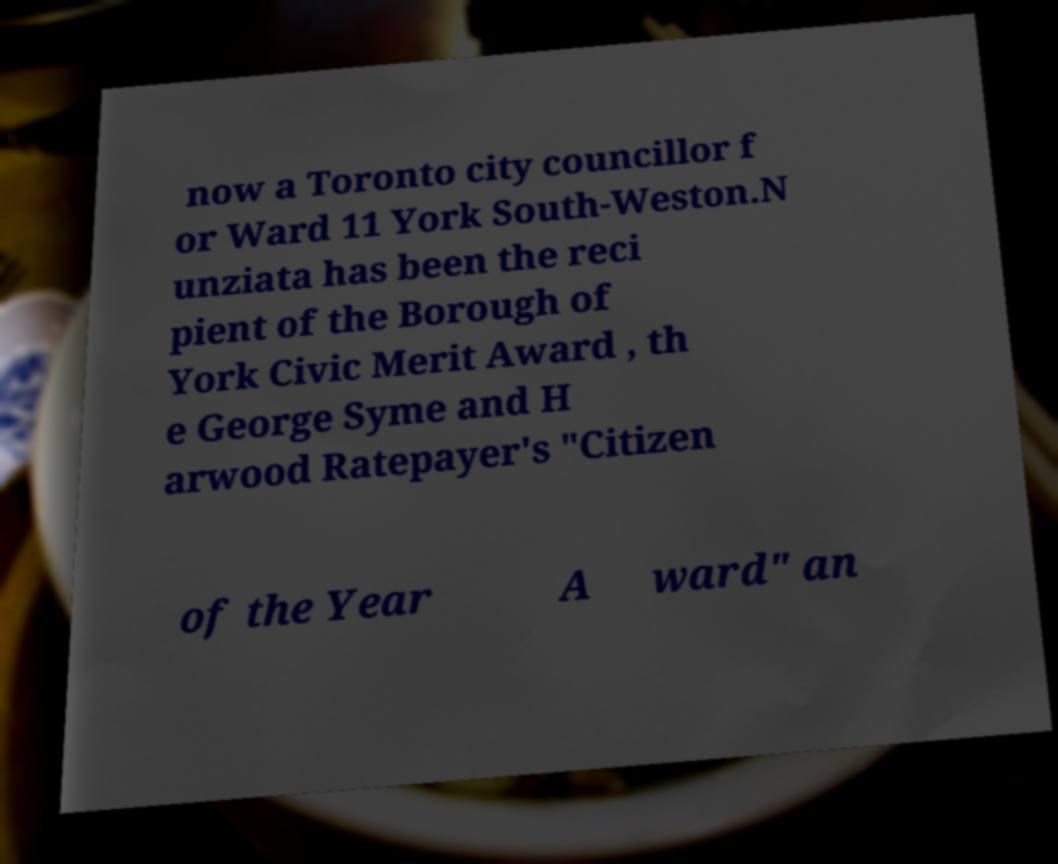Can you accurately transcribe the text from the provided image for me? now a Toronto city councillor f or Ward 11 York South-Weston.N unziata has been the reci pient of the Borough of York Civic Merit Award , th e George Syme and H arwood Ratepayer's "Citizen of the Year A ward" an 